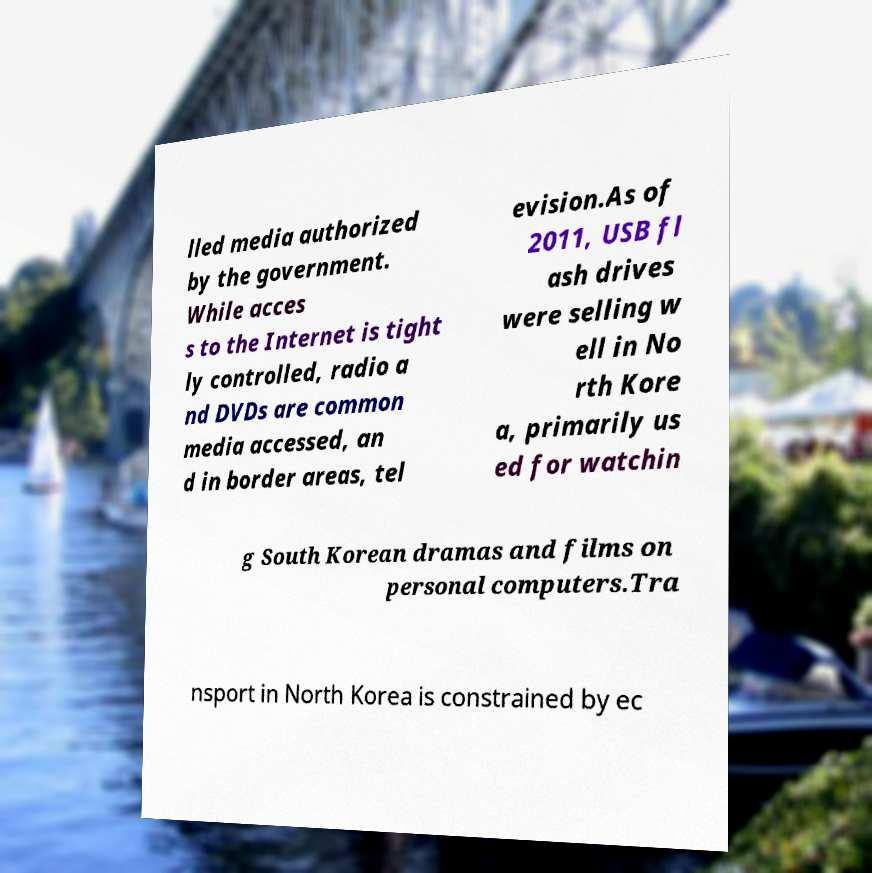I need the written content from this picture converted into text. Can you do that? lled media authorized by the government. While acces s to the Internet is tight ly controlled, radio a nd DVDs are common media accessed, an d in border areas, tel evision.As of 2011, USB fl ash drives were selling w ell in No rth Kore a, primarily us ed for watchin g South Korean dramas and films on personal computers.Tra nsport in North Korea is constrained by ec 